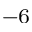Convert formula to latex. <formula><loc_0><loc_0><loc_500><loc_500>^ { - 6 }</formula> 